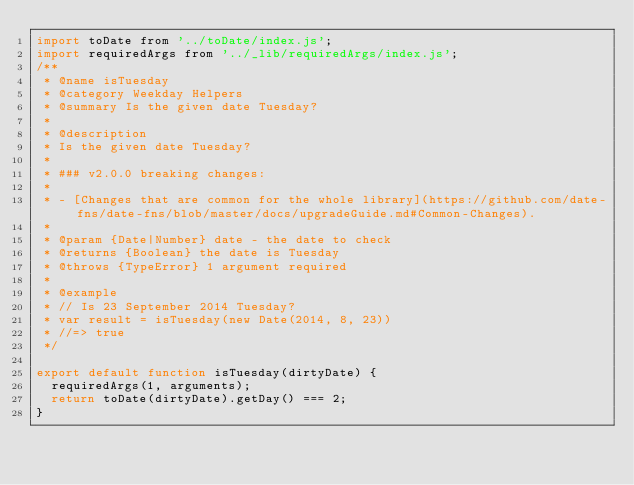Convert code to text. <code><loc_0><loc_0><loc_500><loc_500><_JavaScript_>import toDate from '../toDate/index.js';
import requiredArgs from '../_lib/requiredArgs/index.js';
/**
 * @name isTuesday
 * @category Weekday Helpers
 * @summary Is the given date Tuesday?
 *
 * @description
 * Is the given date Tuesday?
 *
 * ### v2.0.0 breaking changes:
 *
 * - [Changes that are common for the whole library](https://github.com/date-fns/date-fns/blob/master/docs/upgradeGuide.md#Common-Changes).
 *
 * @param {Date|Number} date - the date to check
 * @returns {Boolean} the date is Tuesday
 * @throws {TypeError} 1 argument required
 *
 * @example
 * // Is 23 September 2014 Tuesday?
 * var result = isTuesday(new Date(2014, 8, 23))
 * //=> true
 */

export default function isTuesday(dirtyDate) {
  requiredArgs(1, arguments);
  return toDate(dirtyDate).getDay() === 2;
}</code> 